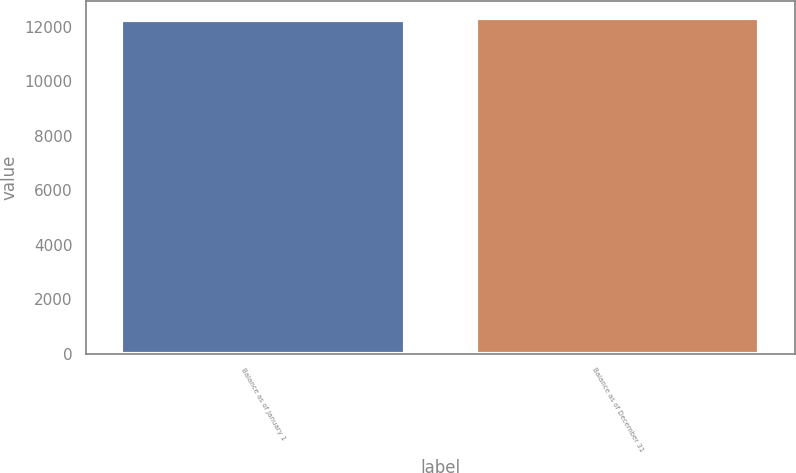Convert chart to OTSL. <chart><loc_0><loc_0><loc_500><loc_500><bar_chart><fcel>Balance as of January 1<fcel>Balance as of December 31<nl><fcel>12255<fcel>12312<nl></chart> 